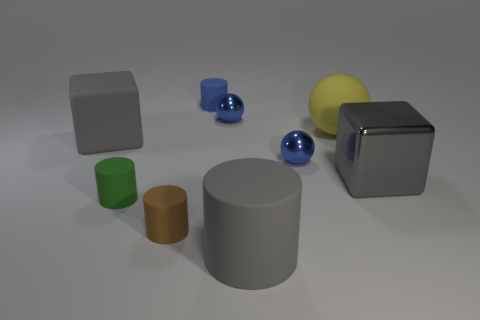Are there any big brown metallic cylinders? Upon reviewing the image, there is a large gray cylinder visible but no big brown metallic cylinders. The gray cylinder might appear metallic but its exact material is not discernible from the image alone, and it is definitely not brown in color. 